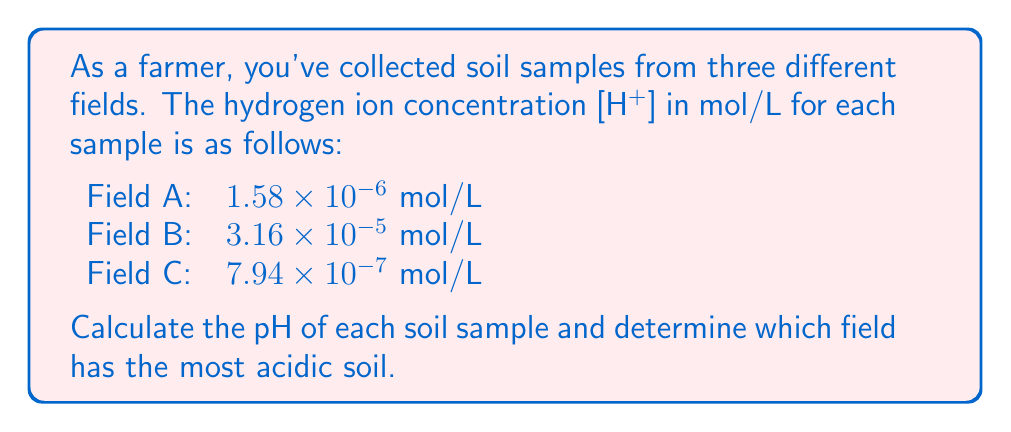Can you solve this math problem? To solve this problem, we'll use the formula for pH:

$$ pH = -\log_{10}[H^+] $$

Let's calculate the pH for each field:

1. Field A: $[H^+] = 1.58 \times 10^{-6}$ mol/L
   $$ pH_A = -\log_{10}(1.58 \times 10^{-6}) = -(-5.8013) = 5.80 $$

2. Field B: $[H^+] = 3.16 \times 10^{-5}$ mol/L
   $$ pH_B = -\log_{10}(3.16 \times 10^{-5}) = -(-4.5001) = 4.50 $$

3. Field C: $[H^+] = 7.94 \times 10^{-7}$ mol/L
   $$ pH_C = -\log_{10}(7.94 \times 10^{-7}) = -(-6.1001) = 6.10 $$

To determine which field has the most acidic soil, we need to compare the pH values. The lower the pH, the more acidic the soil.

Field A: pH 5.80
Field B: pH 4.50
Field C: pH 6.10

Field B has the lowest pH, making it the most acidic.
Answer: Field B (pH 4.50) is the most acidic. 